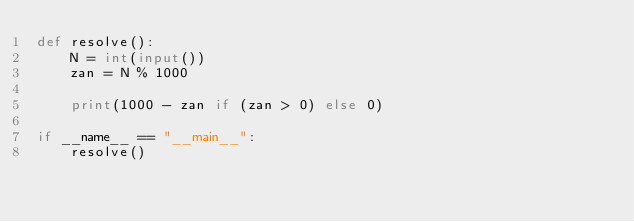<code> <loc_0><loc_0><loc_500><loc_500><_Python_>def resolve():
    N = int(input())
    zan = N % 1000

    print(1000 - zan if (zan > 0) else 0)

if __name__ == "__main__":
    resolve()</code> 